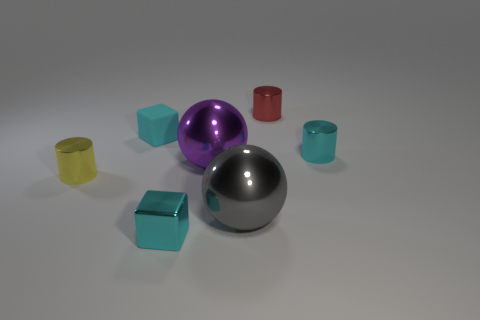Add 1 metal things. How many objects exist? 8 Subtract all spheres. How many objects are left? 5 Add 4 cyan rubber cubes. How many cyan rubber cubes exist? 5 Subtract 0 cyan balls. How many objects are left? 7 Subtract all purple spheres. Subtract all small balls. How many objects are left? 6 Add 5 cyan objects. How many cyan objects are left? 8 